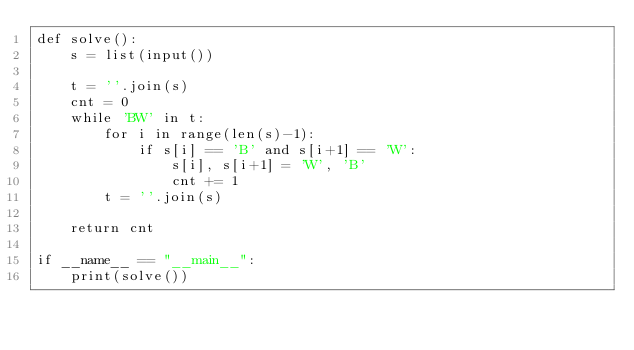<code> <loc_0><loc_0><loc_500><loc_500><_Python_>def solve():
    s = list(input())

    t = ''.join(s)
    cnt = 0
    while 'BW' in t:
        for i in range(len(s)-1):
            if s[i] == 'B' and s[i+1] == 'W':
                s[i], s[i+1] = 'W', 'B'
                cnt += 1
        t = ''.join(s)

    return cnt

if __name__ == "__main__":
    print(solve())

</code> 